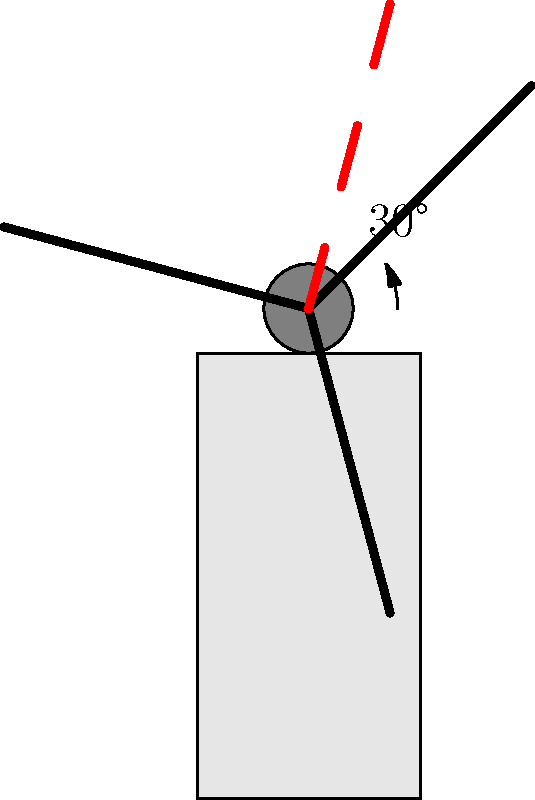During a wind turbine maintenance procedure, a technician needs to rotate one of the blades by 30 degrees clockwise for inspection. If the original position of the blade is represented by the solid line, what is the new position of the blade tip after rotation? To solve this problem, we need to follow these steps:

1. Identify the initial position of the blade: The solid line extending from the hub represents the initial position of the blade.

2. Understand the rotation: The blade needs to be rotated 30 degrees clockwise around the center of the hub.

3. Visualize the rotation: The dashed red line in the diagram represents the new position of the blade after the 30-degree clockwise rotation.

4. Analyze the movement: The tip of the blade (the end furthest from the hub) will move through the largest arc during the rotation.

5. Identify the new position: The tip of the dashed red line indicates the new position of the blade tip after rotation.

The rotation causes the blade tip to move to a position that is lower and more to the right compared to its original position. This new position is crucial for the technician to access and inspect the blade properly.
Answer: The dashed red line's tip 